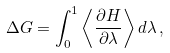<formula> <loc_0><loc_0><loc_500><loc_500>\Delta G = \int _ { 0 } ^ { 1 } \left \langle \frac { \partial H } { \partial \lambda } \right \rangle d \lambda \, ,</formula> 